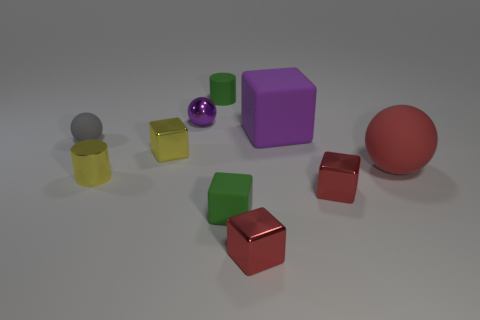Is there a large block on the left side of the tiny cylinder that is on the left side of the small cylinder that is behind the purple matte cube?
Make the answer very short. No. There is a metallic thing that is both right of the small purple object and on the left side of the large cube; what shape is it?
Keep it short and to the point. Cube. Are there any other tiny metal balls of the same color as the metal ball?
Keep it short and to the point. No. There is a shiny object that is on the left side of the yellow block left of the big purple matte thing; what is its color?
Provide a short and direct response. Yellow. What is the size of the rubber ball that is to the left of the green thing in front of the small rubber thing that is behind the tiny gray matte ball?
Provide a short and direct response. Small. Do the tiny purple ball and the big purple block that is behind the large red matte sphere have the same material?
Make the answer very short. No. The green cylinder that is the same material as the big red thing is what size?
Provide a succinct answer. Small. Are there any yellow shiny things of the same shape as the small gray thing?
Your answer should be compact. No. How many objects are either green objects that are in front of the big rubber block or rubber objects?
Your answer should be compact. 5. There is a cube that is the same color as the matte cylinder; what is its size?
Your answer should be very brief. Small. 